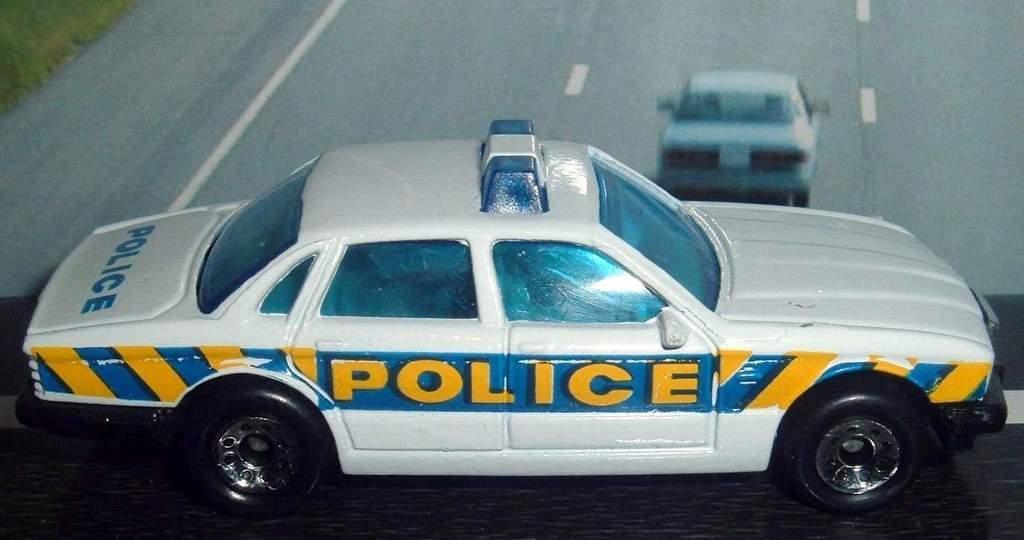Could you give a brief overview of what you see in this image? In this image, we can see a toy car is placed on the black surface. Background we can see a car on the road. Left side top corner, we can see a grass. 